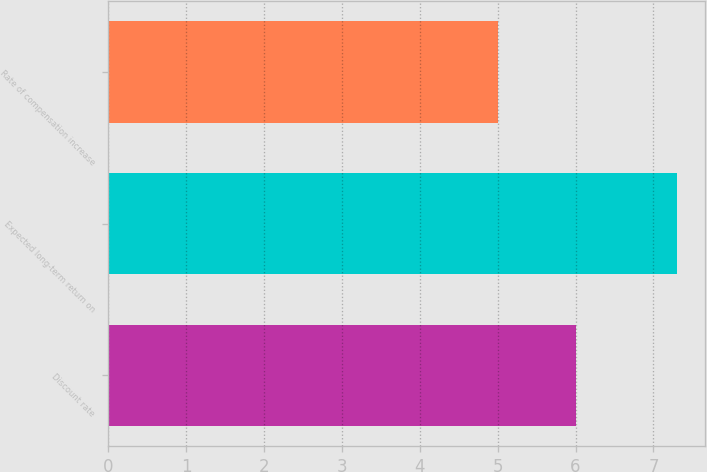Convert chart to OTSL. <chart><loc_0><loc_0><loc_500><loc_500><bar_chart><fcel>Discount rate<fcel>Expected long-term return on<fcel>Rate of compensation increase<nl><fcel>6<fcel>7.3<fcel>5<nl></chart> 